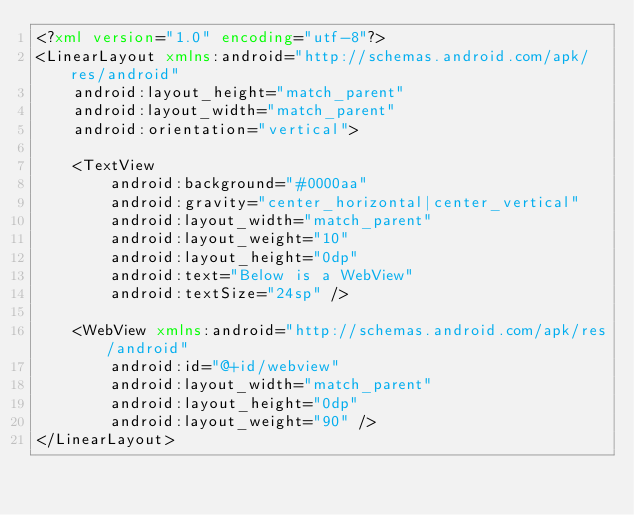<code> <loc_0><loc_0><loc_500><loc_500><_XML_><?xml version="1.0" encoding="utf-8"?>
<LinearLayout xmlns:android="http://schemas.android.com/apk/res/android"
    android:layout_height="match_parent"
    android:layout_width="match_parent"
    android:orientation="vertical">

    <TextView
        android:background="#0000aa"
        android:gravity="center_horizontal|center_vertical"
        android:layout_width="match_parent"
        android:layout_weight="10"
        android:layout_height="0dp"
        android:text="Below is a WebView"
        android:textSize="24sp" />

    <WebView xmlns:android="http://schemas.android.com/apk/res/android"
        android:id="@+id/webview"
        android:layout_width="match_parent"
        android:layout_height="0dp"
        android:layout_weight="90" />
</LinearLayout></code> 